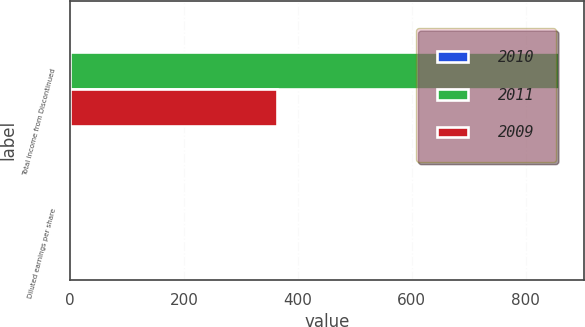Convert chart. <chart><loc_0><loc_0><loc_500><loc_500><stacked_bar_chart><ecel><fcel>Total income from Discontinued<fcel>Diluted earnings per share<nl><fcel>2010<fcel>0.02<fcel>0.02<nl><fcel>2011<fcel>859<fcel>0<nl><fcel>2009<fcel>364<fcel>0<nl></chart> 